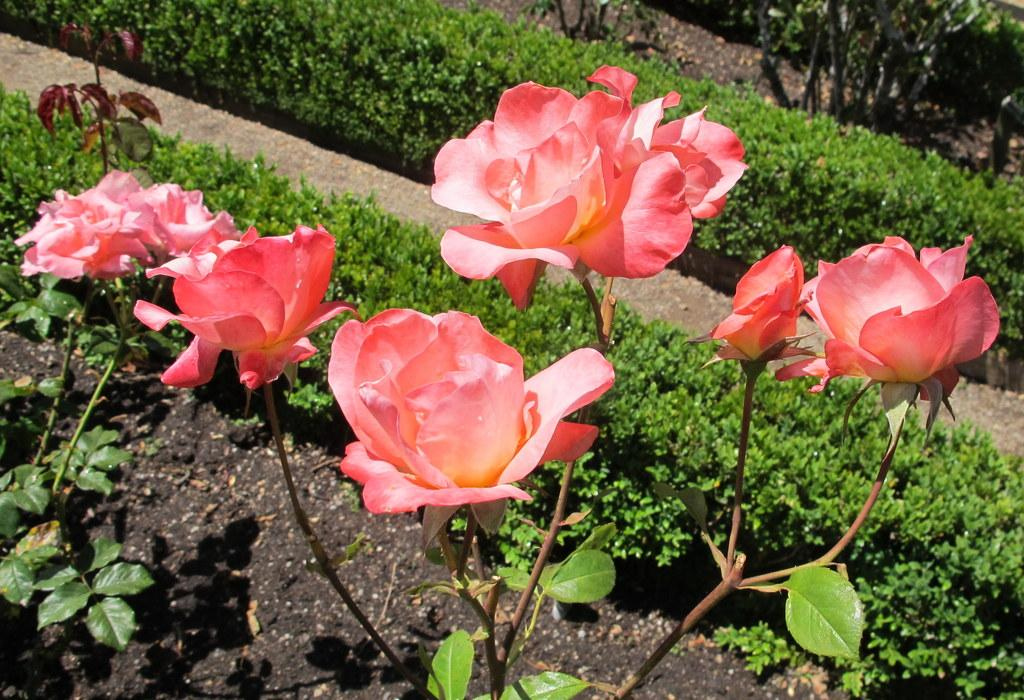What type of flowers can be seen in the image? There are pink flowers in the image. What else is present in the image besides the flowers? There are plants in the image. How many police officers are visible in the image? There are no police officers present in the image; it features pink flowers and plants. What type of flower is being used as a train in the image? There is no flower being used as a train in the image; it only features pink flowers and plants. 